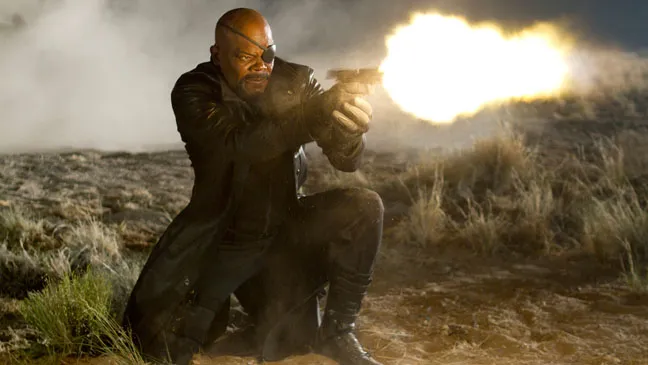Imagine what could be occurring off-screen that leads to this intense moment? Off-screen, it is easy to imagine that there could be a fierce battle or chase taking place. Perhaps our character has been tracking a formidable adversary across this desolate terrain, resulting in a climactic confrontation. Alternatively, he might be defending against multiple foes closing in from different directions, necessitating his resolute stand. The environment suggests that strategic maneuvers have led him to this point where he must take a decisive action, possibly to protect something valuable or crucial to his mission. Could there be a science fiction element to this scene? Absolutely! Given the dramatic lighting and the character's high-tech weaponry, this scene could easily be part of a science fiction narrative. Imagine there's more than meets the eye – perhaps advanced alien technology is at play, or the character is clashing with intergalactic foes in a battle for control over a powerful artifact buried in this remote location. The dust and smoke could be residues from highly advanced tech or an alien atmosphere generator that has malfunctioned or been sabotaged. Create a very creative scenario involving mystical elements. The scene is set on the ancient battlefield of Takamoto, a lost desert that holds secrets of mystical powers. Our character, a sorcerer-warrior, guards the Portal of Eternity, an ancient gateway that bridges realms. The bright orange flames from his weapon are not mere bullets, but spells enchanted with dragon fire, capable of vanquishing ethereal beings. Invisible to the mundane eye, spirits of the ancient Takamoto tribe rose from the sands, assisting him in the fight against a malevolent warlock attempting to open the portal and unleash chaos upon Earth. 